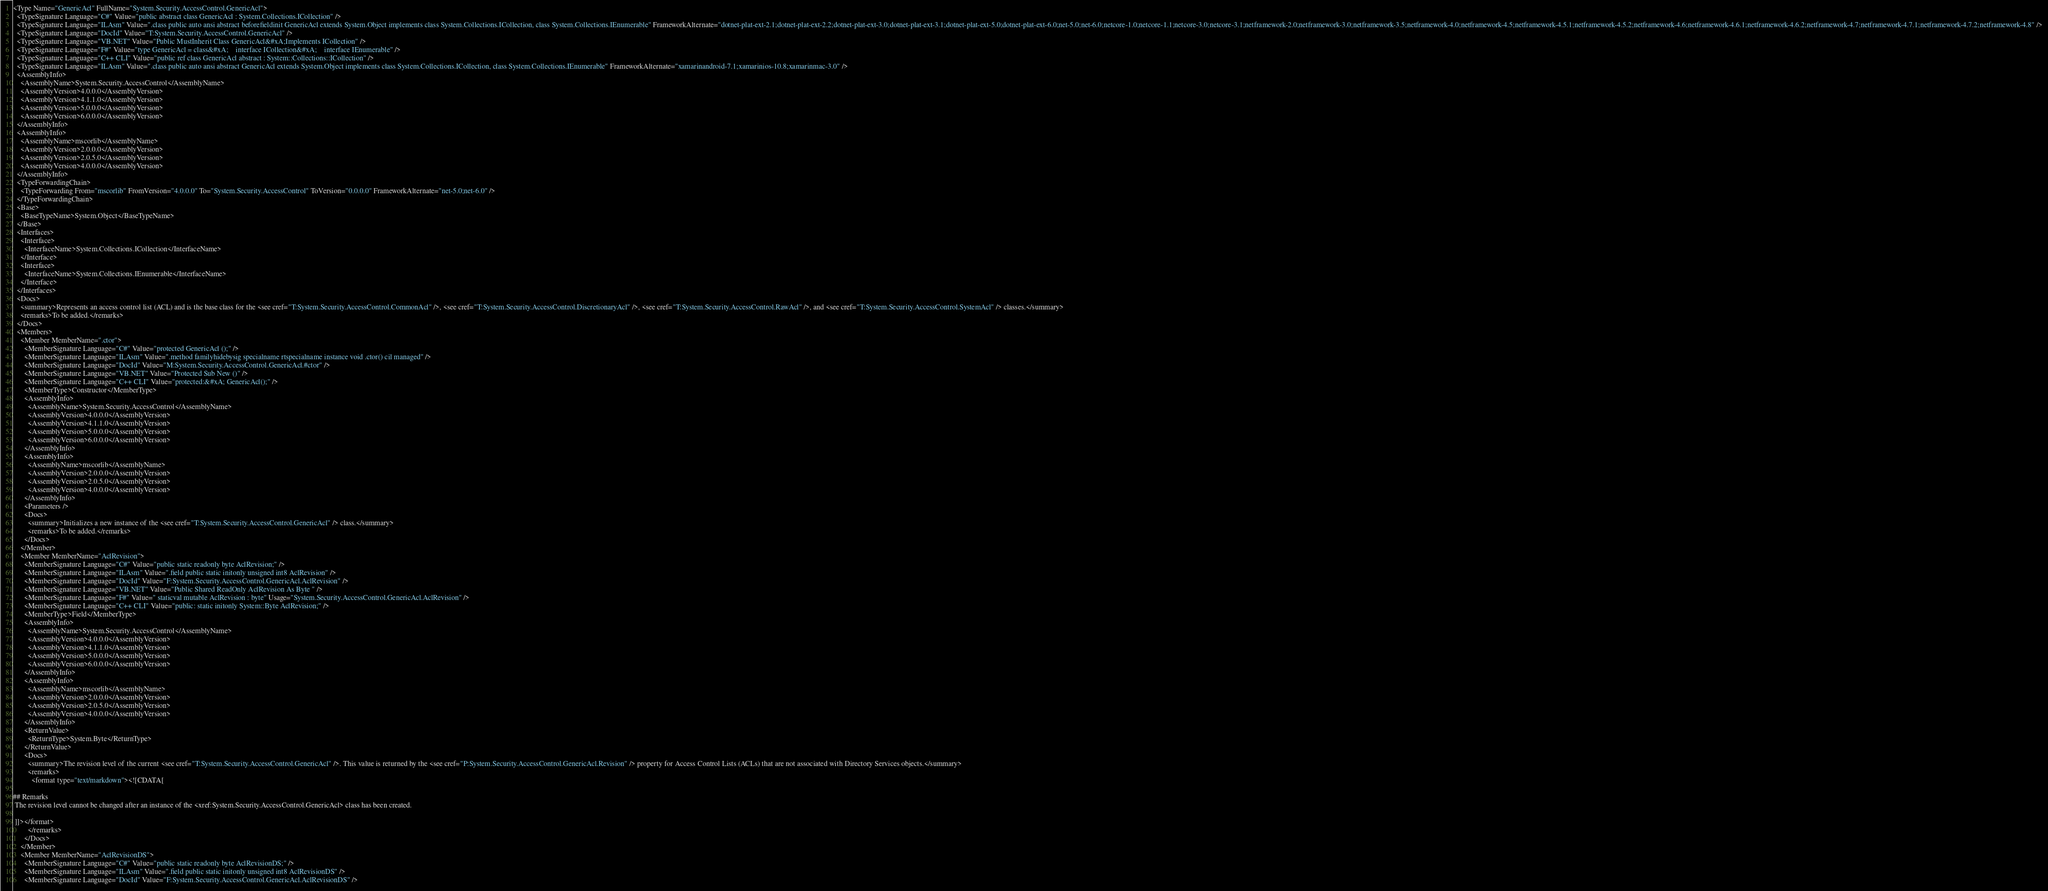<code> <loc_0><loc_0><loc_500><loc_500><_XML_><Type Name="GenericAcl" FullName="System.Security.AccessControl.GenericAcl">
  <TypeSignature Language="C#" Value="public abstract class GenericAcl : System.Collections.ICollection" />
  <TypeSignature Language="ILAsm" Value=".class public auto ansi abstract beforefieldinit GenericAcl extends System.Object implements class System.Collections.ICollection, class System.Collections.IEnumerable" FrameworkAlternate="dotnet-plat-ext-2.1;dotnet-plat-ext-2.2;dotnet-plat-ext-3.0;dotnet-plat-ext-3.1;dotnet-plat-ext-5.0;dotnet-plat-ext-6.0;net-5.0;net-6.0;netcore-1.0;netcore-1.1;netcore-3.0;netcore-3.1;netframework-2.0;netframework-3.0;netframework-3.5;netframework-4.0;netframework-4.5;netframework-4.5.1;netframework-4.5.2;netframework-4.6;netframework-4.6.1;netframework-4.6.2;netframework-4.7;netframework-4.7.1;netframework-4.7.2;netframework-4.8" />
  <TypeSignature Language="DocId" Value="T:System.Security.AccessControl.GenericAcl" />
  <TypeSignature Language="VB.NET" Value="Public MustInherit Class GenericAcl&#xA;Implements ICollection" />
  <TypeSignature Language="F#" Value="type GenericAcl = class&#xA;    interface ICollection&#xA;    interface IEnumerable" />
  <TypeSignature Language="C++ CLI" Value="public ref class GenericAcl abstract : System::Collections::ICollection" />
  <TypeSignature Language="ILAsm" Value=".class public auto ansi abstract GenericAcl extends System.Object implements class System.Collections.ICollection, class System.Collections.IEnumerable" FrameworkAlternate="xamarinandroid-7.1;xamarinios-10.8;xamarinmac-3.0" />
  <AssemblyInfo>
    <AssemblyName>System.Security.AccessControl</AssemblyName>
    <AssemblyVersion>4.0.0.0</AssemblyVersion>
    <AssemblyVersion>4.1.1.0</AssemblyVersion>
    <AssemblyVersion>5.0.0.0</AssemblyVersion>
    <AssemblyVersion>6.0.0.0</AssemblyVersion>
  </AssemblyInfo>
  <AssemblyInfo>
    <AssemblyName>mscorlib</AssemblyName>
    <AssemblyVersion>2.0.0.0</AssemblyVersion>
    <AssemblyVersion>2.0.5.0</AssemblyVersion>
    <AssemblyVersion>4.0.0.0</AssemblyVersion>
  </AssemblyInfo>
  <TypeForwardingChain>
    <TypeForwarding From="mscorlib" FromVersion="4.0.0.0" To="System.Security.AccessControl" ToVersion="0.0.0.0" FrameworkAlternate="net-5.0;net-6.0" />
  </TypeForwardingChain>
  <Base>
    <BaseTypeName>System.Object</BaseTypeName>
  </Base>
  <Interfaces>
    <Interface>
      <InterfaceName>System.Collections.ICollection</InterfaceName>
    </Interface>
    <Interface>
      <InterfaceName>System.Collections.IEnumerable</InterfaceName>
    </Interface>
  </Interfaces>
  <Docs>
    <summary>Represents an access control list (ACL) and is the base class for the <see cref="T:System.Security.AccessControl.CommonAcl" />, <see cref="T:System.Security.AccessControl.DiscretionaryAcl" />, <see cref="T:System.Security.AccessControl.RawAcl" />, and <see cref="T:System.Security.AccessControl.SystemAcl" /> classes.</summary>
    <remarks>To be added.</remarks>
  </Docs>
  <Members>
    <Member MemberName=".ctor">
      <MemberSignature Language="C#" Value="protected GenericAcl ();" />
      <MemberSignature Language="ILAsm" Value=".method familyhidebysig specialname rtspecialname instance void .ctor() cil managed" />
      <MemberSignature Language="DocId" Value="M:System.Security.AccessControl.GenericAcl.#ctor" />
      <MemberSignature Language="VB.NET" Value="Protected Sub New ()" />
      <MemberSignature Language="C++ CLI" Value="protected:&#xA; GenericAcl();" />
      <MemberType>Constructor</MemberType>
      <AssemblyInfo>
        <AssemblyName>System.Security.AccessControl</AssemblyName>
        <AssemblyVersion>4.0.0.0</AssemblyVersion>
        <AssemblyVersion>4.1.1.0</AssemblyVersion>
        <AssemblyVersion>5.0.0.0</AssemblyVersion>
        <AssemblyVersion>6.0.0.0</AssemblyVersion>
      </AssemblyInfo>
      <AssemblyInfo>
        <AssemblyName>mscorlib</AssemblyName>
        <AssemblyVersion>2.0.0.0</AssemblyVersion>
        <AssemblyVersion>2.0.5.0</AssemblyVersion>
        <AssemblyVersion>4.0.0.0</AssemblyVersion>
      </AssemblyInfo>
      <Parameters />
      <Docs>
        <summary>Initializes a new instance of the <see cref="T:System.Security.AccessControl.GenericAcl" /> class.</summary>
        <remarks>To be added.</remarks>
      </Docs>
    </Member>
    <Member MemberName="AclRevision">
      <MemberSignature Language="C#" Value="public static readonly byte AclRevision;" />
      <MemberSignature Language="ILAsm" Value=".field public static initonly unsigned int8 AclRevision" />
      <MemberSignature Language="DocId" Value="F:System.Security.AccessControl.GenericAcl.AclRevision" />
      <MemberSignature Language="VB.NET" Value="Public Shared ReadOnly AclRevision As Byte " />
      <MemberSignature Language="F#" Value=" staticval mutable AclRevision : byte" Usage="System.Security.AccessControl.GenericAcl.AclRevision" />
      <MemberSignature Language="C++ CLI" Value="public: static initonly System::Byte AclRevision;" />
      <MemberType>Field</MemberType>
      <AssemblyInfo>
        <AssemblyName>System.Security.AccessControl</AssemblyName>
        <AssemblyVersion>4.0.0.0</AssemblyVersion>
        <AssemblyVersion>4.1.1.0</AssemblyVersion>
        <AssemblyVersion>5.0.0.0</AssemblyVersion>
        <AssemblyVersion>6.0.0.0</AssemblyVersion>
      </AssemblyInfo>
      <AssemblyInfo>
        <AssemblyName>mscorlib</AssemblyName>
        <AssemblyVersion>2.0.0.0</AssemblyVersion>
        <AssemblyVersion>2.0.5.0</AssemblyVersion>
        <AssemblyVersion>4.0.0.0</AssemblyVersion>
      </AssemblyInfo>
      <ReturnValue>
        <ReturnType>System.Byte</ReturnType>
      </ReturnValue>
      <Docs>
        <summary>The revision level of the current <see cref="T:System.Security.AccessControl.GenericAcl" />. This value is returned by the <see cref="P:System.Security.AccessControl.GenericAcl.Revision" /> property for Access Control Lists (ACLs) that are not associated with Directory Services objects.</summary>
        <remarks>
          <format type="text/markdown"><![CDATA[  
  
## Remarks  
 The revision level cannot be changed after an instance of the <xref:System.Security.AccessControl.GenericAcl> class has been created.  
  
 ]]></format>
        </remarks>
      </Docs>
    </Member>
    <Member MemberName="AclRevisionDS">
      <MemberSignature Language="C#" Value="public static readonly byte AclRevisionDS;" />
      <MemberSignature Language="ILAsm" Value=".field public static initonly unsigned int8 AclRevisionDS" />
      <MemberSignature Language="DocId" Value="F:System.Security.AccessControl.GenericAcl.AclRevisionDS" /></code> 